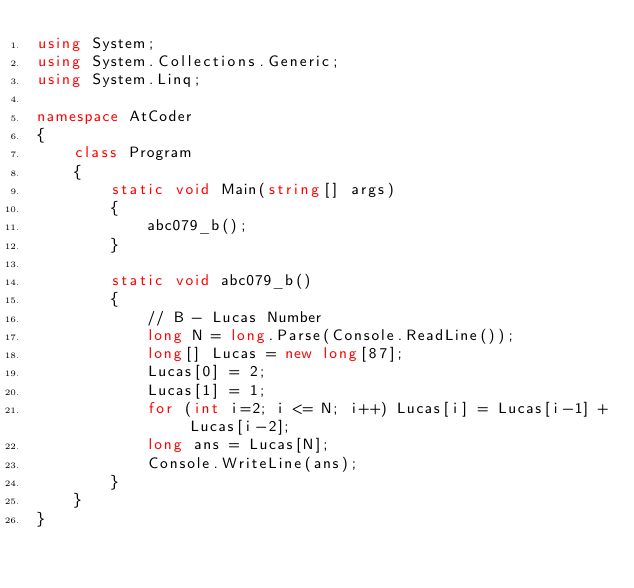<code> <loc_0><loc_0><loc_500><loc_500><_C#_>using System;
using System.Collections.Generic;
using System.Linq;

namespace AtCoder
{
    class Program
    {
        static void Main(string[] args)
        {
            abc079_b();
        }

        static void abc079_b()
        {
            // B - Lucas Number
            long N = long.Parse(Console.ReadLine());
            long[] Lucas = new long[87];
            Lucas[0] = 2;
            Lucas[1] = 1;
            for (int i=2; i <= N; i++) Lucas[i] = Lucas[i-1] + Lucas[i-2];
            long ans = Lucas[N];
            Console.WriteLine(ans);
        }
    }
}</code> 